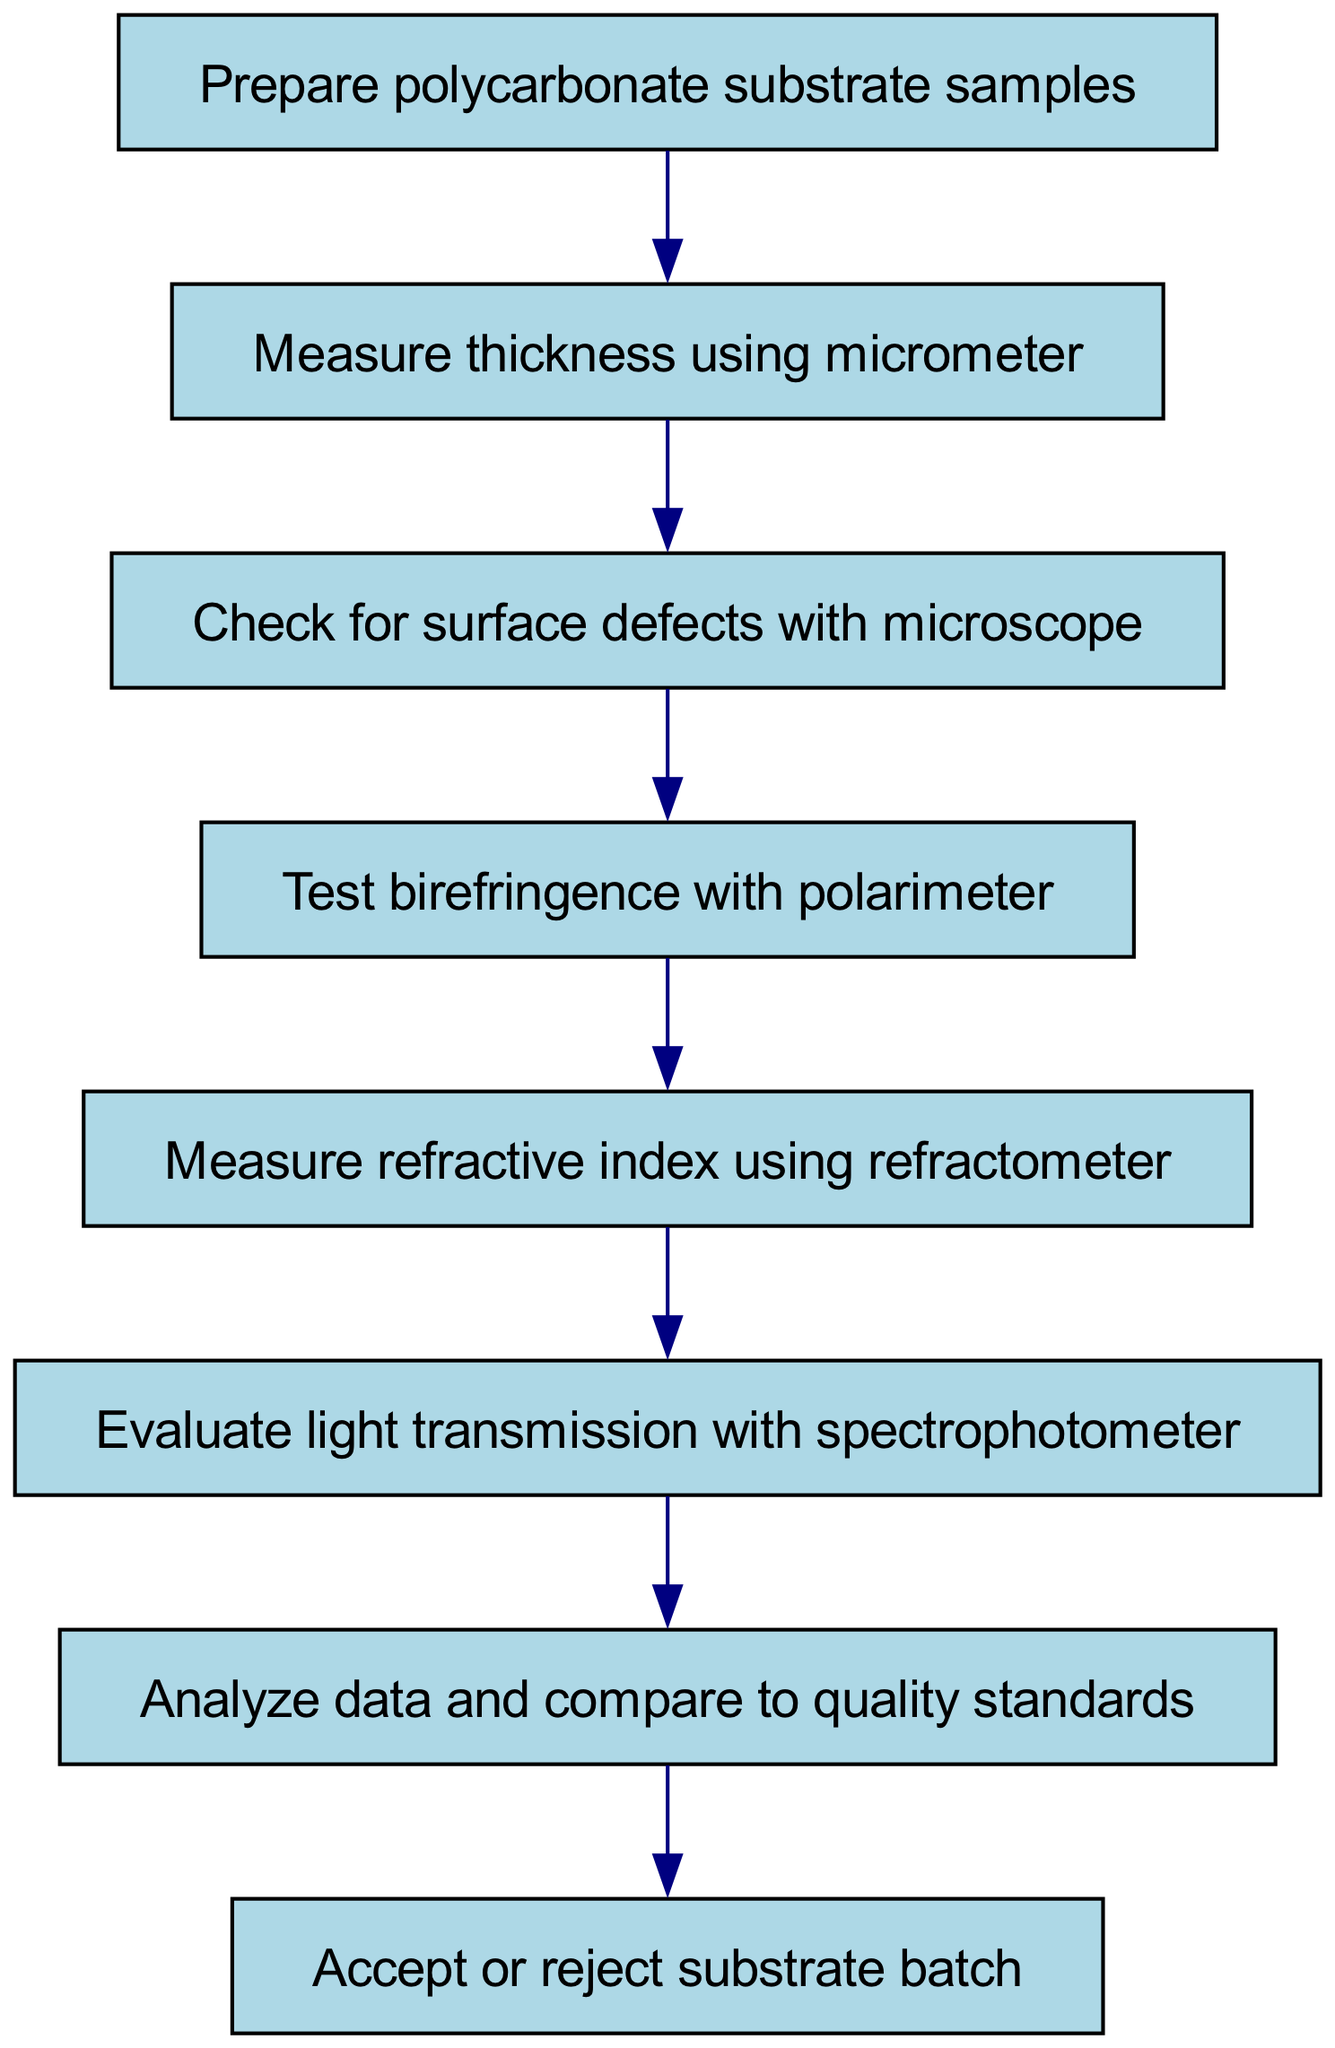What is the first step in the testing procedure? The first step in the diagram is to prepare polycarbonate substrate samples, which is indicated at the starting point of the flowchart.
Answer: Prepare polycarbonate substrate samples How many steps are there in total? By counting the nodes in the diagram, we see there are eight steps labeled from 1 to 8.
Answer: 8 What follows after measuring thickness? After measuring thickness using the micrometer, the next step is to check for surface defects with a microscope, as shown by the directed edge leading from the thickness measurement to the surface defect check.
Answer: Check for surface defects with microscope Which step involves the use of a polarimeter? The step that involves the use of a polarimeter is testing birefringence, which is the fourth step in the flowchart.
Answer: Test birefringence with polarimeter What is the final decision point in the process? The final decision point in the flowchart is to accept or reject the substrate batch, which is the final step labeled as step 8.
Answer: Accept or reject substrate batch How many measurements must be taken before data analysis? Before data analysis can occur, six measurements must be taken according to the flow from steps 2 to 6, completing all previous tests.
Answer: 6 Which instrument is used to evaluate light transmission? The instrument used to evaluate light transmission is a spectrophotometer, which is pointed out in the diagram at the sixth step.
Answer: Spectrophotometer What happens if the quality standards are not met? If the quality standards are not met after data analysis, the substrate batch would be rejected, as per the final decision point in the flowchart.
Answer: Reject substrate batch 